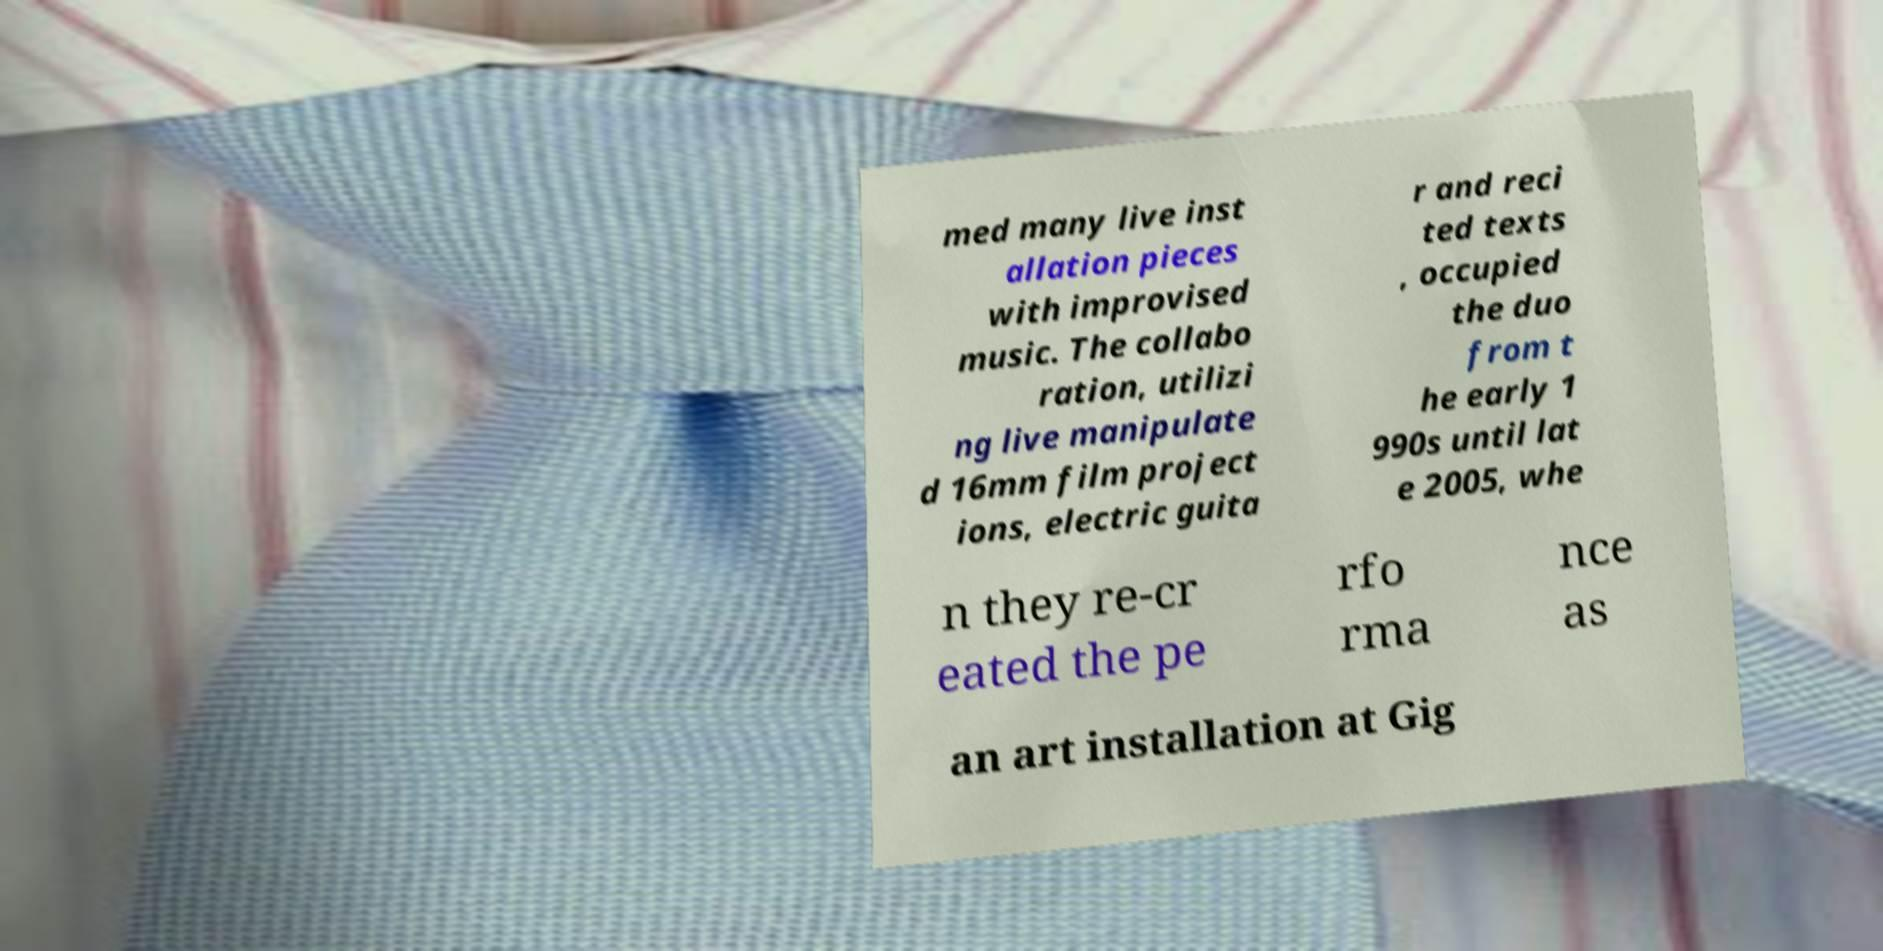Could you assist in decoding the text presented in this image and type it out clearly? med many live inst allation pieces with improvised music. The collabo ration, utilizi ng live manipulate d 16mm film project ions, electric guita r and reci ted texts , occupied the duo from t he early 1 990s until lat e 2005, whe n they re-cr eated the pe rfo rma nce as an art installation at Gig 